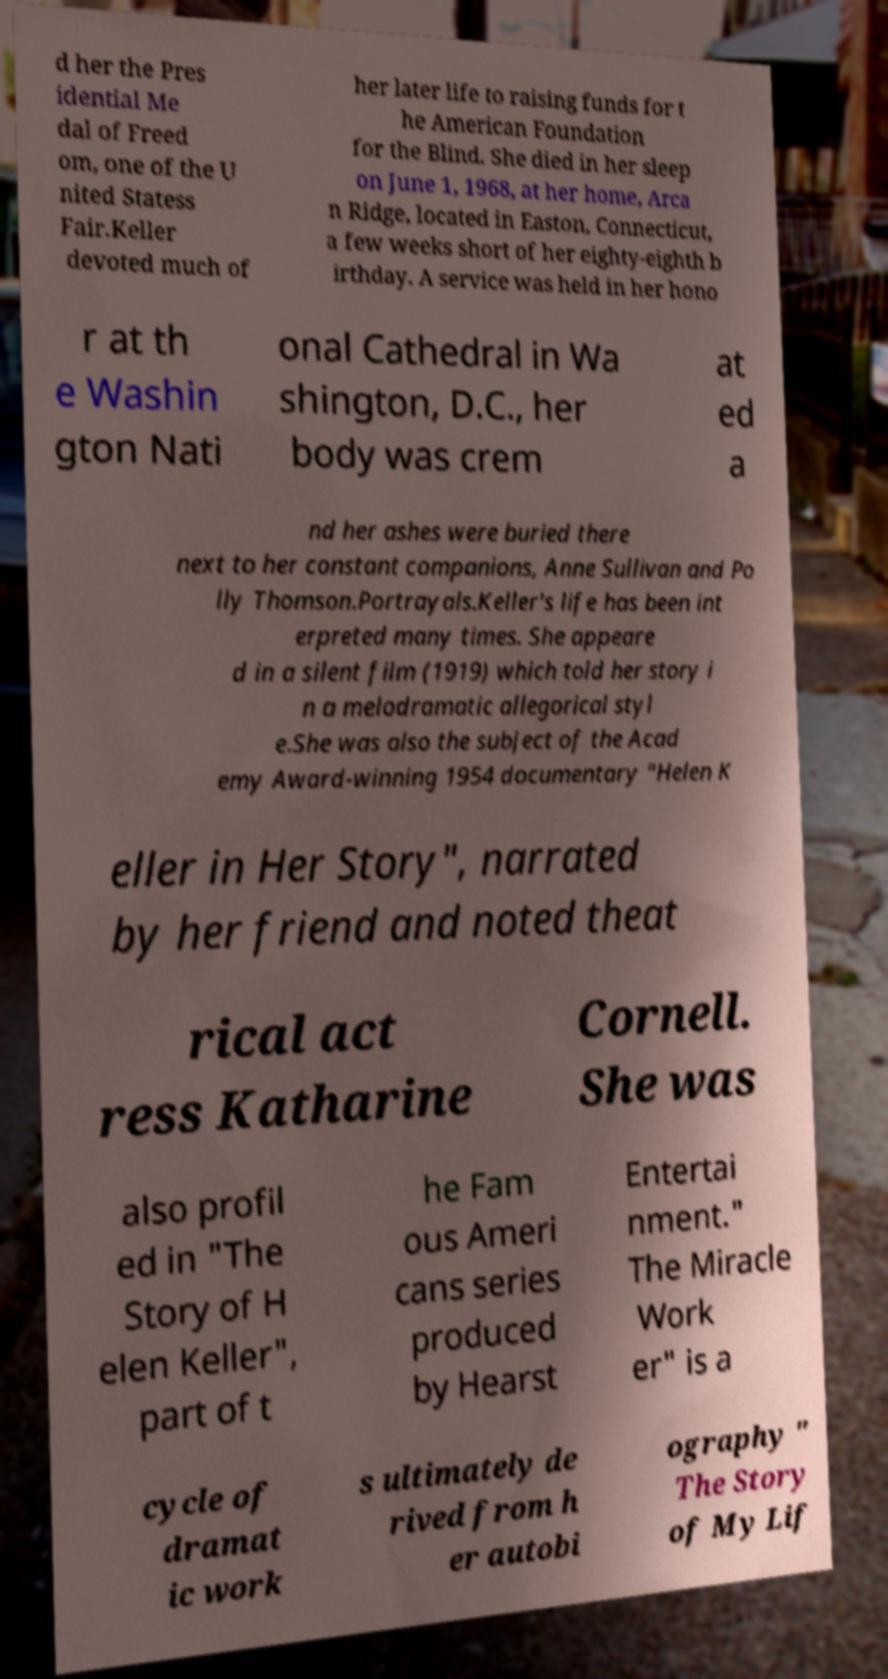I need the written content from this picture converted into text. Can you do that? d her the Pres idential Me dal of Freed om, one of the U nited Statess Fair.Keller devoted much of her later life to raising funds for t he American Foundation for the Blind. She died in her sleep on June 1, 1968, at her home, Arca n Ridge, located in Easton, Connecticut, a few weeks short of her eighty-eighth b irthday. A service was held in her hono r at th e Washin gton Nati onal Cathedral in Wa shington, D.C., her body was crem at ed a nd her ashes were buried there next to her constant companions, Anne Sullivan and Po lly Thomson.Portrayals.Keller's life has been int erpreted many times. She appeare d in a silent film (1919) which told her story i n a melodramatic allegorical styl e.She was also the subject of the Acad emy Award-winning 1954 documentary "Helen K eller in Her Story", narrated by her friend and noted theat rical act ress Katharine Cornell. She was also profil ed in "The Story of H elen Keller", part of t he Fam ous Ameri cans series produced by Hearst Entertai nment." The Miracle Work er" is a cycle of dramat ic work s ultimately de rived from h er autobi ography " The Story of My Lif 